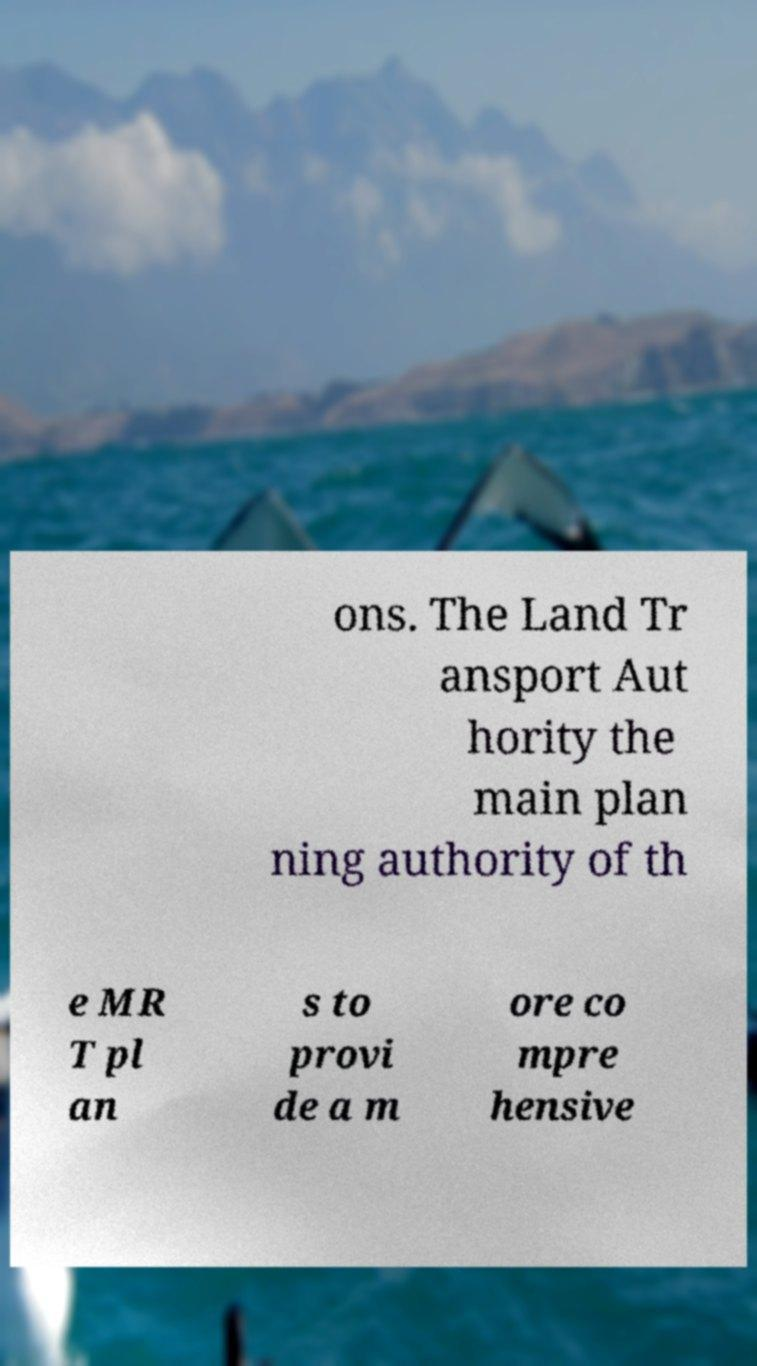Can you accurately transcribe the text from the provided image for me? ons. The Land Tr ansport Aut hority the main plan ning authority of th e MR T pl an s to provi de a m ore co mpre hensive 